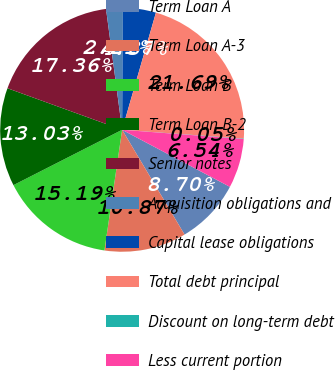Convert chart to OTSL. <chart><loc_0><loc_0><loc_500><loc_500><pie_chart><fcel>Term Loan A<fcel>Term Loan A-3<fcel>Term Loan B<fcel>Term Loan B-2<fcel>Senior notes<fcel>Acquisition obligations and<fcel>Capital lease obligations<fcel>Total debt principal<fcel>Discount on long-term debt<fcel>Less current portion<nl><fcel>8.7%<fcel>10.87%<fcel>15.19%<fcel>13.03%<fcel>17.36%<fcel>2.21%<fcel>4.37%<fcel>21.69%<fcel>0.05%<fcel>6.54%<nl></chart> 